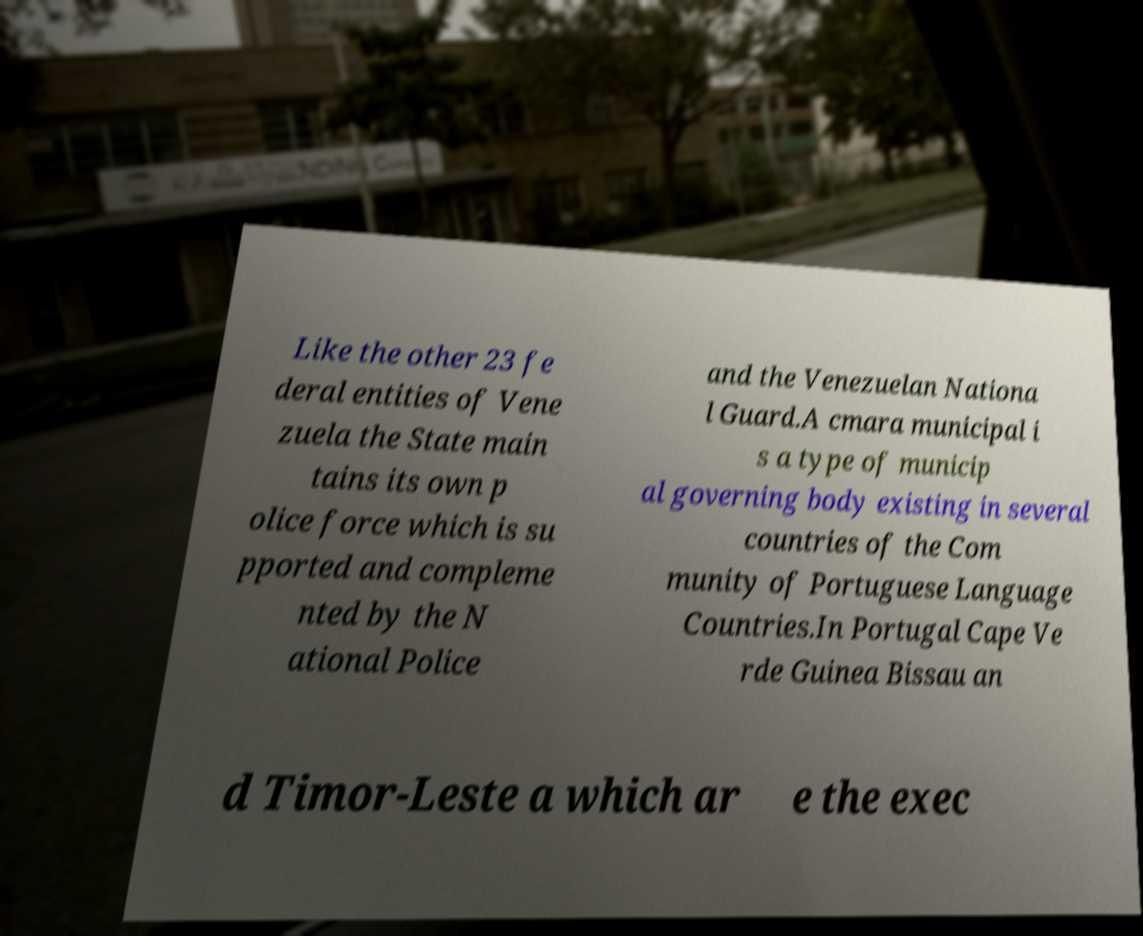I need the written content from this picture converted into text. Can you do that? Like the other 23 fe deral entities of Vene zuela the State main tains its own p olice force which is su pported and compleme nted by the N ational Police and the Venezuelan Nationa l Guard.A cmara municipal i s a type of municip al governing body existing in several countries of the Com munity of Portuguese Language Countries.In Portugal Cape Ve rde Guinea Bissau an d Timor-Leste a which ar e the exec 